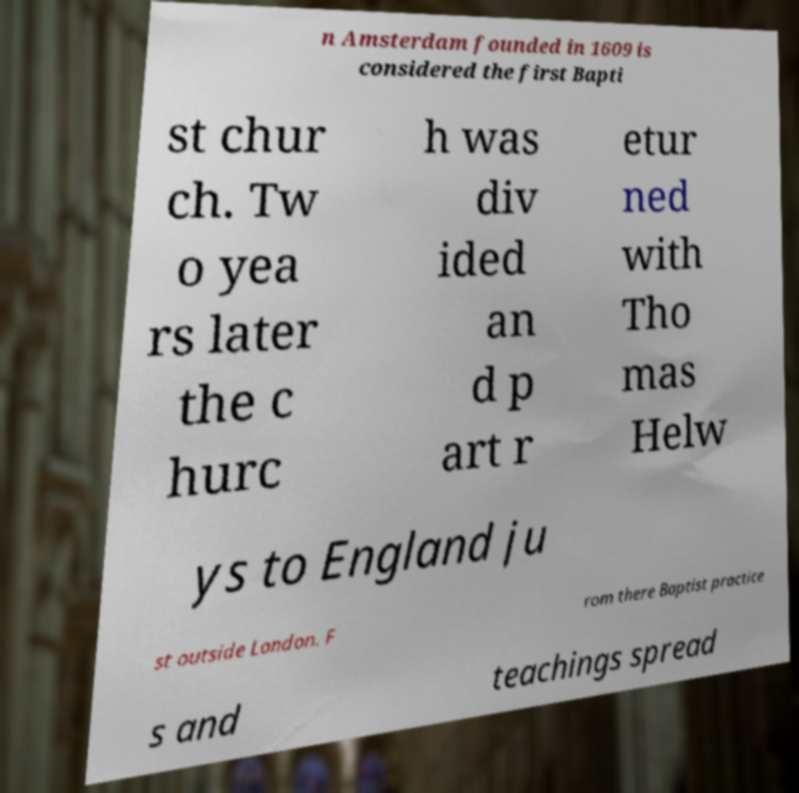There's text embedded in this image that I need extracted. Can you transcribe it verbatim? n Amsterdam founded in 1609 is considered the first Bapti st chur ch. Tw o yea rs later the c hurc h was div ided an d p art r etur ned with Tho mas Helw ys to England ju st outside London. F rom there Baptist practice s and teachings spread 